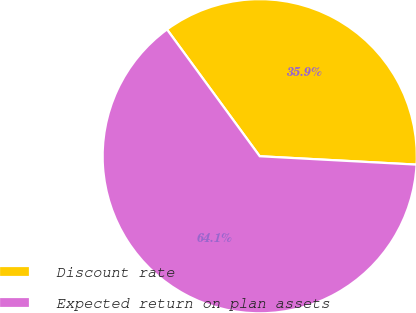Convert chart to OTSL. <chart><loc_0><loc_0><loc_500><loc_500><pie_chart><fcel>Discount rate<fcel>Expected return on plan assets<nl><fcel>35.9%<fcel>64.1%<nl></chart> 